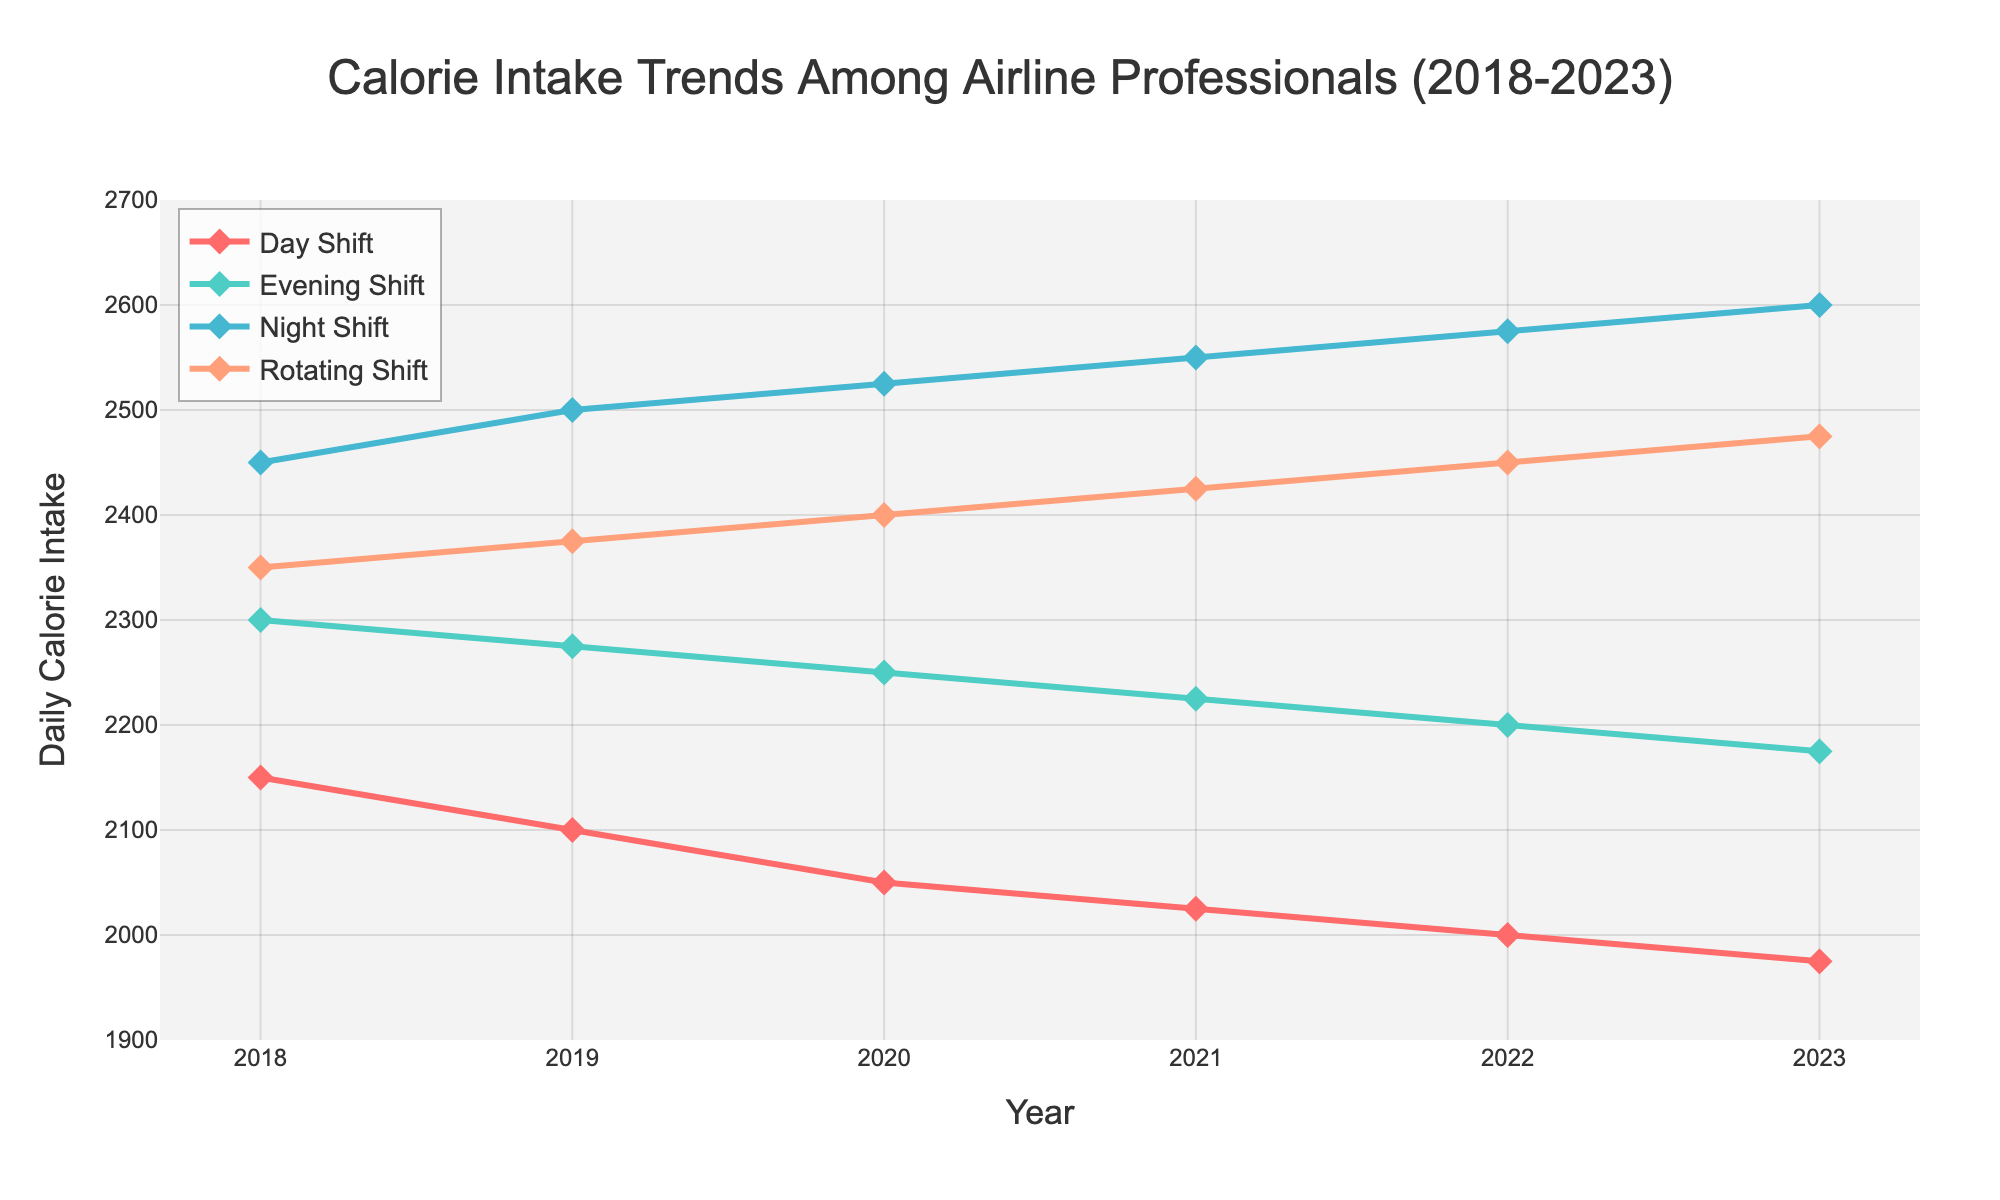what is the trend in calorie intake for the night shift from 2018 to 2023? The calorie intake for the night shift shows a consistent increase each year from 2450 in 2018 to 2600 in 2023.
Answer: Increase from 2450 to 2600 which shift had the highest calorie intake in 2023? The night shift had the highest calorie intake in 2023 with a value of 2600.
Answer: Night Shift what is the difference in calorie intake between the rotating shift and the day shift in 2023? The calorie intake for the rotating shift in 2023 is 2475 and for the day shift, it is 1975. The difference is 2475 - 1975 = 500.
Answer: 500 how did the calorie intake for the evening shift change from 2018 to 2023? The calorie intake for the evening shift decreased from 2300 in 2018 to 2175 in 2023.
Answer: Decrease from 2300 to 2175 what is the average calorie intake for the rotating shift over the 5-year period from 2018 to 2023? Sum the calorie intake values for the rotating shift from 2018 to 2023: 2350 + 2375 + 2400 + 2425 + 2450 + 2475 = 14475. Average = 14475 / 6 = 2412.5.
Answer: 2412.5 which year had the highest average calorie intake across all shifts? Calculate the average for each year and compare: 
2018: (2150 + 2300 + 2450 + 2350) / 4 = 2312.5,
2019: (2100 + 2275 + 2500 + 2375) / 4 = 2312.5,
2020: (2050 + 2250 + 2525 + 2400) / 4 = 2306.25,
2021: (2025 + 2225 + 2550 + 2425) / 4 = 2306.25,
2022: (2000 + 2200 + 2575 + 2450) / 4 = 2306.25,
2023: (1975 + 2175 + 2600 + 2475) / 4 = 2306.25.
2018 and 2019 have the highest average intake of 2312.5.
Answer: 2018 and 2019 how much did the calorie intake for the day shift decline from 2018 to 2023? The calorie intake for the day shift in 2018 is 2150 and in 2023 is 1975. The decline is 2150 - 1975 = 175.
Answer: 175 compare the calorie intake change for the evening shift and the night shift from 2020 to 2023. 2020 Evening Shift: 2250, 2023: 2175. Change: 2175 - 2250 = -75.
2020 Night Shift: 2525, 2023: 2600. Change: 2600 - 2525 = +75.
Evening shift decreases by 75, night shift increases by 75.
Answer: Evening: -75, Night: +75 what patterns can you observe in the calorie intake for the rotating shift from 2018 to 2023? The calorie intake for the rotating shift steadily increases every year from 2350 in 2018 to 2475 in 2023.
Answer: Steady increase 